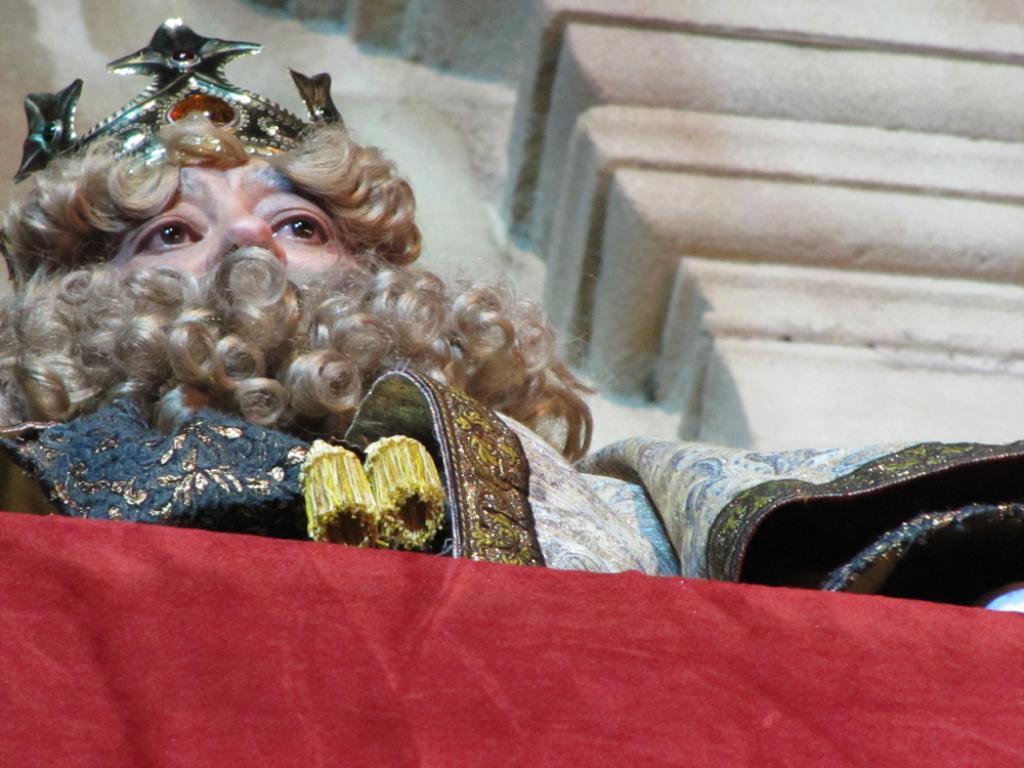In one or two sentences, can you explain what this image depicts? In this image we can see a person. A person is wearing a crown on his head. There is a red color object at the bottom of the image. 